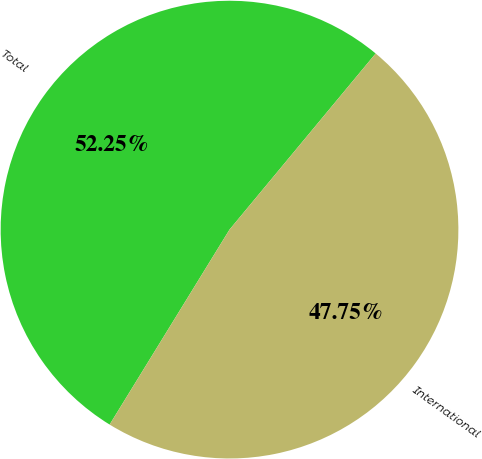<chart> <loc_0><loc_0><loc_500><loc_500><pie_chart><fcel>Total<fcel>International<nl><fcel>52.25%<fcel>47.75%<nl></chart> 